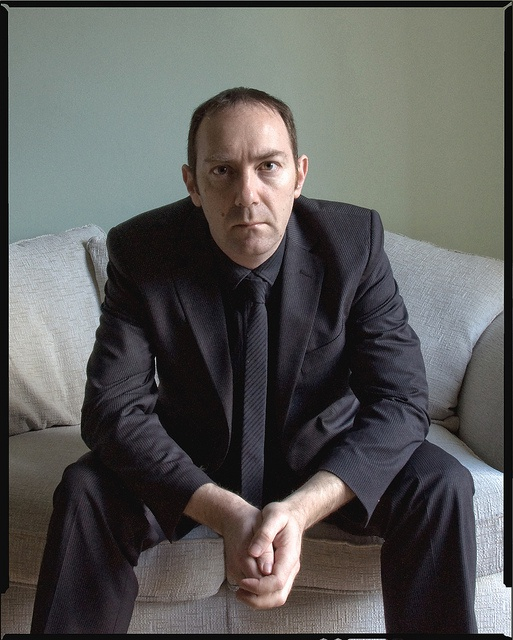Describe the objects in this image and their specific colors. I can see people in gray, black, and maroon tones, couch in gray, darkgray, black, and lightgray tones, and tie in gray and black tones in this image. 